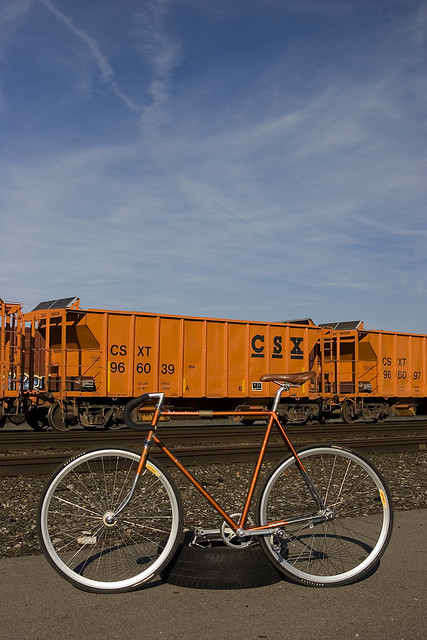Please identify all text content in this image. 39 CS 96 XT 60 97 98 CS C S X 